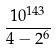Convert formula to latex. <formula><loc_0><loc_0><loc_500><loc_500>\frac { 1 0 ^ { 1 4 3 } } { 4 - 2 ^ { 6 } }</formula> 